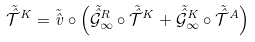Convert formula to latex. <formula><loc_0><loc_0><loc_500><loc_500>\tilde { \hat { \mathcal { T } } } ^ { K } = \tilde { \hat { v } } \circ \left ( \tilde { \hat { \mathcal { G } } } _ { \infty } ^ { R } \circ \tilde { \hat { \mathcal { T } } } ^ { K } + \tilde { \hat { \mathcal { G } } } _ { \infty } ^ { K } \circ \tilde { \hat { \mathcal { T } } } ^ { A } \right )</formula> 